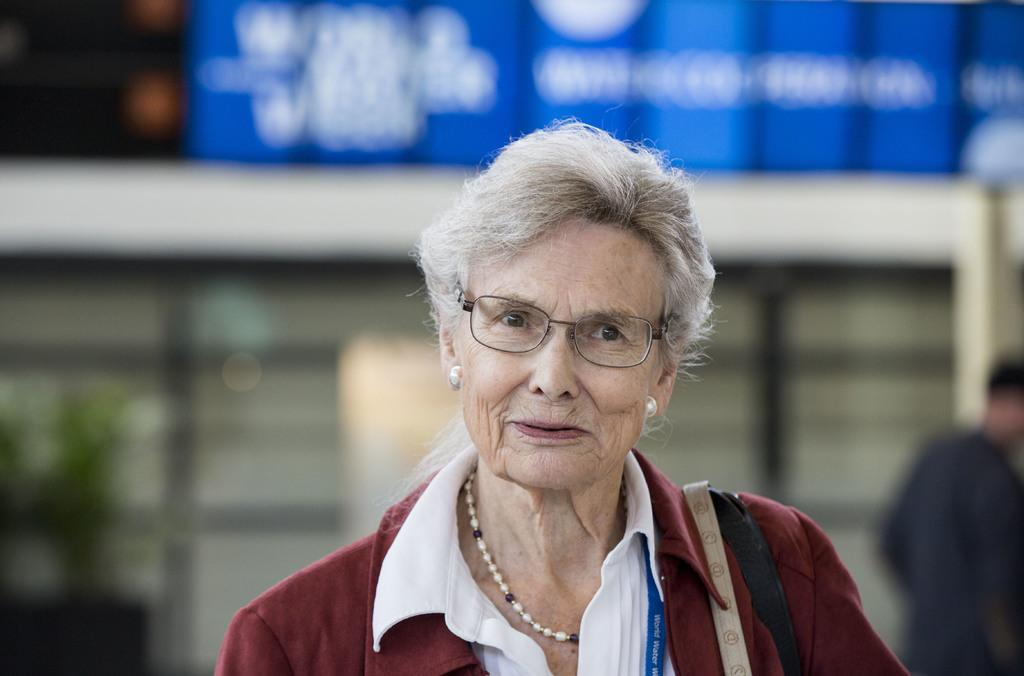Who is present in the image? There is a woman in the image. What is the woman's facial expression? The woman is smiling. What type of book is the woman holding in the image? There is no book present in the image; it only features a woman who is smiling. 